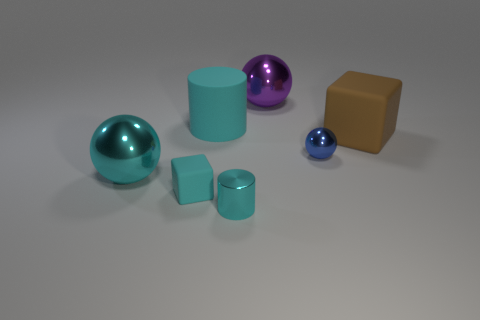What shape is the big rubber object that is the same color as the tiny shiny cylinder?
Your response must be concise. Cylinder. Are the ball right of the large purple metallic thing and the big cyan cylinder made of the same material?
Keep it short and to the point. No. What color is the rubber cylinder that is the same size as the brown block?
Offer a terse response. Cyan. Are there any shiny spheres of the same color as the small cube?
Offer a terse response. Yes. There is a cyan sphere that is the same material as the tiny cyan cylinder; what size is it?
Provide a succinct answer. Large. There is a ball that is the same color as the metallic cylinder; what is its size?
Provide a short and direct response. Large. What number of other objects are there of the same size as the cyan metal ball?
Keep it short and to the point. 3. There is a big sphere that is left of the big purple sphere; what is its material?
Your answer should be compact. Metal. There is a cyan rubber thing in front of the cylinder behind the metal object that is in front of the large cyan ball; what is its shape?
Offer a terse response. Cube. Do the brown matte object and the blue metal object have the same size?
Offer a very short reply. No. 